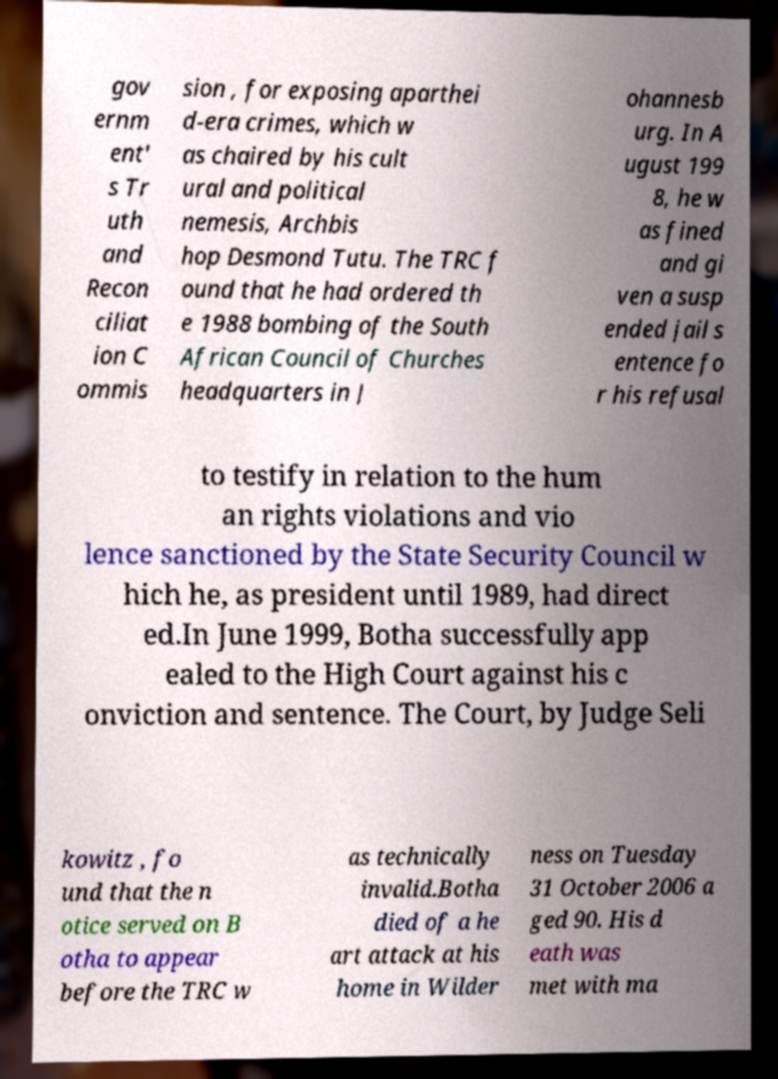I need the written content from this picture converted into text. Can you do that? gov ernm ent' s Tr uth and Recon ciliat ion C ommis sion , for exposing aparthei d-era crimes, which w as chaired by his cult ural and political nemesis, Archbis hop Desmond Tutu. The TRC f ound that he had ordered th e 1988 bombing of the South African Council of Churches headquarters in J ohannesb urg. In A ugust 199 8, he w as fined and gi ven a susp ended jail s entence fo r his refusal to testify in relation to the hum an rights violations and vio lence sanctioned by the State Security Council w hich he, as president until 1989, had direct ed.In June 1999, Botha successfully app ealed to the High Court against his c onviction and sentence. The Court, by Judge Seli kowitz , fo und that the n otice served on B otha to appear before the TRC w as technically invalid.Botha died of a he art attack at his home in Wilder ness on Tuesday 31 October 2006 a ged 90. His d eath was met with ma 